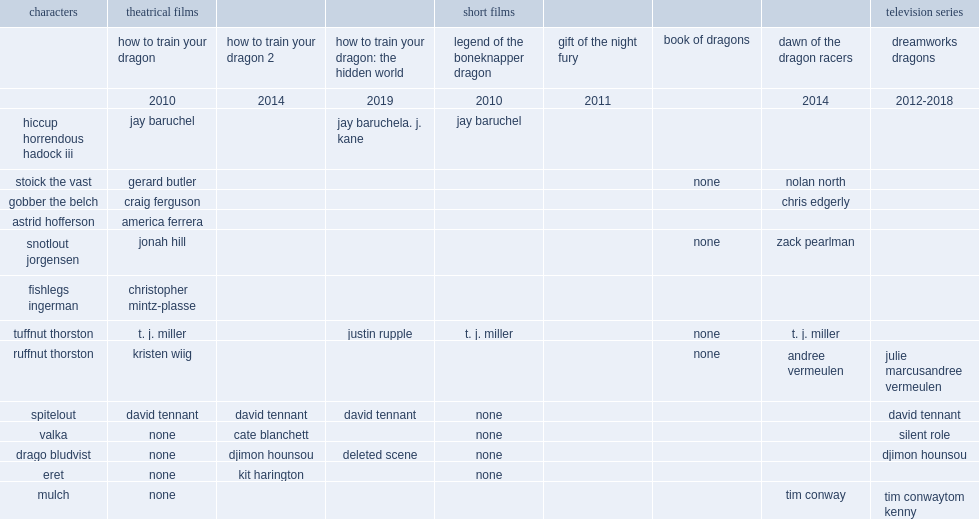When did the film dawn of the dragon racers release? 2014.0. 